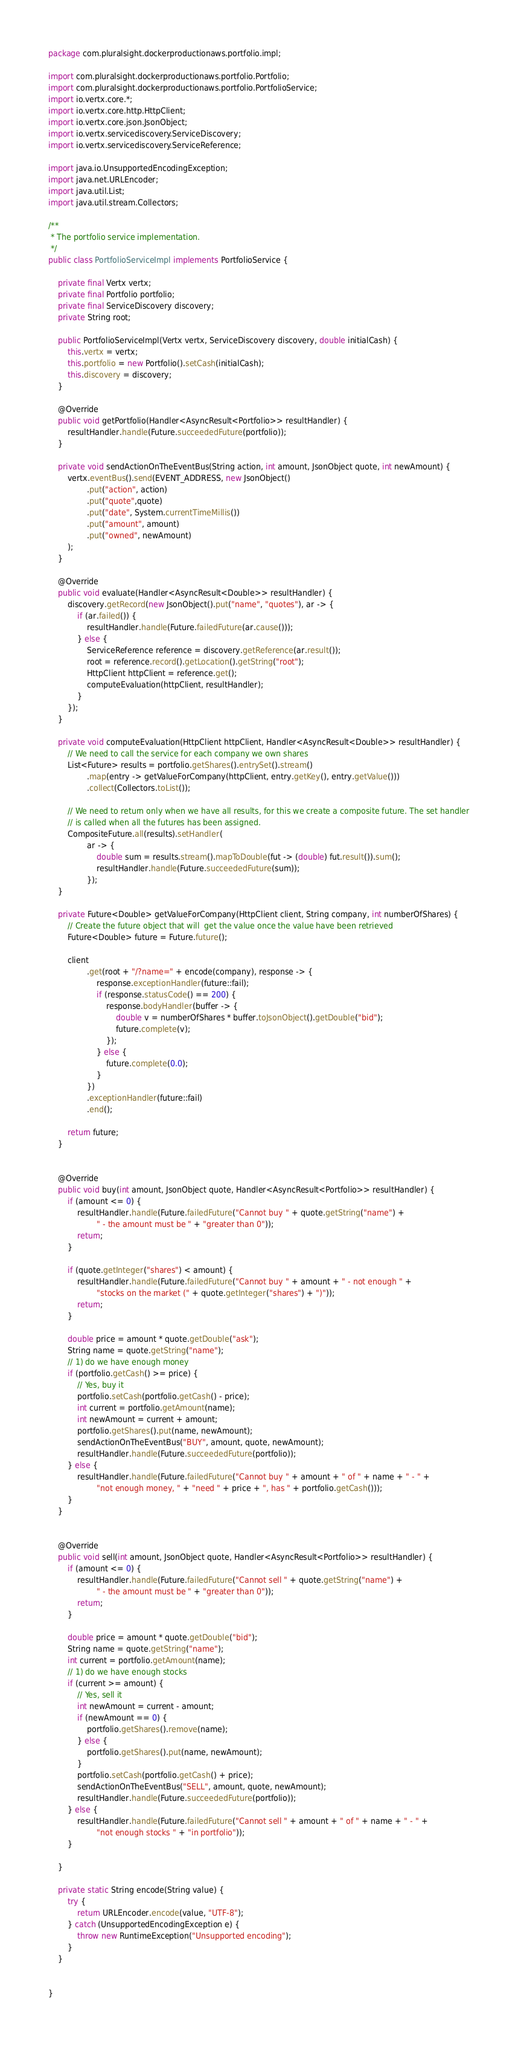<code> <loc_0><loc_0><loc_500><loc_500><_Java_>package com.pluralsight.dockerproductionaws.portfolio.impl;

import com.pluralsight.dockerproductionaws.portfolio.Portfolio;
import com.pluralsight.dockerproductionaws.portfolio.PortfolioService;
import io.vertx.core.*;
import io.vertx.core.http.HttpClient;
import io.vertx.core.json.JsonObject;
import io.vertx.servicediscovery.ServiceDiscovery;
import io.vertx.servicediscovery.ServiceReference;

import java.io.UnsupportedEncodingException;
import java.net.URLEncoder;
import java.util.List;
import java.util.stream.Collectors;

/**
 * The portfolio service implementation.
 */
public class PortfolioServiceImpl implements PortfolioService {

    private final Vertx vertx;
    private final Portfolio portfolio;
    private final ServiceDiscovery discovery;
    private String root;

    public PortfolioServiceImpl(Vertx vertx, ServiceDiscovery discovery, double initialCash) {
        this.vertx = vertx;
        this.portfolio = new Portfolio().setCash(initialCash);
        this.discovery = discovery;
    }

    @Override
    public void getPortfolio(Handler<AsyncResult<Portfolio>> resultHandler) {
        resultHandler.handle(Future.succeededFuture(portfolio));
    }

    private void sendActionOnTheEventBus(String action, int amount, JsonObject quote, int newAmount) {
        vertx.eventBus().send(EVENT_ADDRESS, new JsonObject()
                .put("action", action)
                .put("quote",quote)
                .put("date", System.currentTimeMillis())
                .put("amount", amount)
                .put("owned", newAmount)
        );
    }

    @Override
    public void evaluate(Handler<AsyncResult<Double>> resultHandler) {
        discovery.getRecord(new JsonObject().put("name", "quotes"), ar -> {
            if (ar.failed()) {
                resultHandler.handle(Future.failedFuture(ar.cause()));
            } else {
                ServiceReference reference = discovery.getReference(ar.result());
                root = reference.record().getLocation().getString("root");
                HttpClient httpClient = reference.get();
                computeEvaluation(httpClient, resultHandler);
            }
        });
    }

    private void computeEvaluation(HttpClient httpClient, Handler<AsyncResult<Double>> resultHandler) {
        // We need to call the service for each company we own shares
        List<Future> results = portfolio.getShares().entrySet().stream()
                .map(entry -> getValueForCompany(httpClient, entry.getKey(), entry.getValue()))
                .collect(Collectors.toList());

        // We need to return only when we have all results, for this we create a composite future. The set handler
        // is called when all the futures has been assigned.
        CompositeFuture.all(results).setHandler(
                ar -> {
                    double sum = results.stream().mapToDouble(fut -> (double) fut.result()).sum();
                    resultHandler.handle(Future.succeededFuture(sum));
                });
    }

    private Future<Double> getValueForCompany(HttpClient client, String company, int numberOfShares) {
        // Create the future object that will  get the value once the value have been retrieved
        Future<Double> future = Future.future();

        client
                .get(root + "/?name=" + encode(company), response -> {
                    response.exceptionHandler(future::fail);
                    if (response.statusCode() == 200) {
                        response.bodyHandler(buffer -> {
                            double v = numberOfShares * buffer.toJsonObject().getDouble("bid");
                            future.complete(v);
                        });
                    } else {
                        future.complete(0.0);
                    }
                })
                .exceptionHandler(future::fail)
                .end();

        return future;
    }


    @Override
    public void buy(int amount, JsonObject quote, Handler<AsyncResult<Portfolio>> resultHandler) {
        if (amount <= 0) {
            resultHandler.handle(Future.failedFuture("Cannot buy " + quote.getString("name") +
                    " - the amount must be " + "greater than 0"));
            return;
        }

        if (quote.getInteger("shares") < amount) {
            resultHandler.handle(Future.failedFuture("Cannot buy " + amount + " - not enough " +
                    "stocks on the market (" + quote.getInteger("shares") + ")"));
            return;
        }

        double price = amount * quote.getDouble("ask");
        String name = quote.getString("name");
        // 1) do we have enough money
        if (portfolio.getCash() >= price) {
            // Yes, buy it
            portfolio.setCash(portfolio.getCash() - price);
            int current = portfolio.getAmount(name);
            int newAmount = current + amount;
            portfolio.getShares().put(name, newAmount);
            sendActionOnTheEventBus("BUY", amount, quote, newAmount);
            resultHandler.handle(Future.succeededFuture(portfolio));
        } else {
            resultHandler.handle(Future.failedFuture("Cannot buy " + amount + " of " + name + " - " +
                    "not enough money, " + "need " + price + ", has " + portfolio.getCash()));
        }
    }


    @Override
    public void sell(int amount, JsonObject quote, Handler<AsyncResult<Portfolio>> resultHandler) {
        if (amount <= 0) {
            resultHandler.handle(Future.failedFuture("Cannot sell " + quote.getString("name") +
                    " - the amount must be " + "greater than 0"));
            return;
        }

        double price = amount * quote.getDouble("bid");
        String name = quote.getString("name");
        int current = portfolio.getAmount(name);
        // 1) do we have enough stocks
        if (current >= amount) {
            // Yes, sell it
            int newAmount = current - amount;
            if (newAmount == 0) {
                portfolio.getShares().remove(name);
            } else {
                portfolio.getShares().put(name, newAmount);
            }
            portfolio.setCash(portfolio.getCash() + price);
            sendActionOnTheEventBus("SELL", amount, quote, newAmount);
            resultHandler.handle(Future.succeededFuture(portfolio));
        } else {
            resultHandler.handle(Future.failedFuture("Cannot sell " + amount + " of " + name + " - " +
                    "not enough stocks " + "in portfolio"));
        }

    }

    private static String encode(String value) {
        try {
            return URLEncoder.encode(value, "UTF-8");
        } catch (UnsupportedEncodingException e) {
            throw new RuntimeException("Unsupported encoding");
        }
    }


}
</code> 